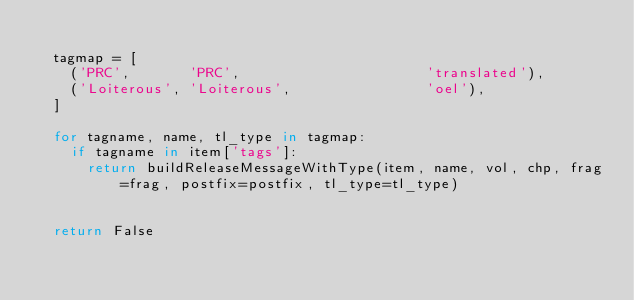<code> <loc_0><loc_0><loc_500><loc_500><_Python_>
	tagmap = [
		('PRC',       'PRC',                      'translated'),
		('Loiterous', 'Loiterous',                'oel'),
	]

	for tagname, name, tl_type in tagmap:
		if tagname in item['tags']:
			return buildReleaseMessageWithType(item, name, vol, chp, frag=frag, postfix=postfix, tl_type=tl_type)


	return False
	</code> 